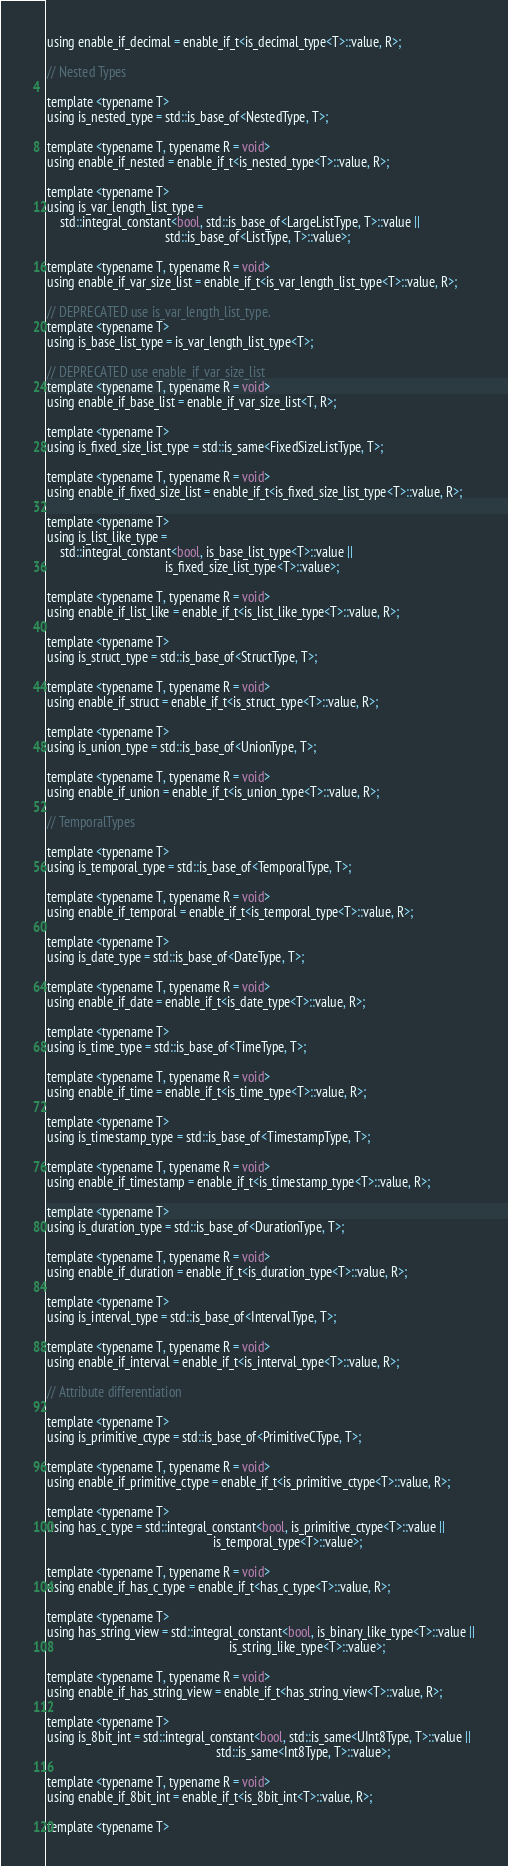Convert code to text. <code><loc_0><loc_0><loc_500><loc_500><_C_>using enable_if_decimal = enable_if_t<is_decimal_type<T>::value, R>;

// Nested Types

template <typename T>
using is_nested_type = std::is_base_of<NestedType, T>;

template <typename T, typename R = void>
using enable_if_nested = enable_if_t<is_nested_type<T>::value, R>;

template <typename T>
using is_var_length_list_type =
    std::integral_constant<bool, std::is_base_of<LargeListType, T>::value ||
                                     std::is_base_of<ListType, T>::value>;

template <typename T, typename R = void>
using enable_if_var_size_list = enable_if_t<is_var_length_list_type<T>::value, R>;

// DEPRECATED use is_var_length_list_type.
template <typename T>
using is_base_list_type = is_var_length_list_type<T>;

// DEPRECATED use enable_if_var_size_list
template <typename T, typename R = void>
using enable_if_base_list = enable_if_var_size_list<T, R>;

template <typename T>
using is_fixed_size_list_type = std::is_same<FixedSizeListType, T>;

template <typename T, typename R = void>
using enable_if_fixed_size_list = enable_if_t<is_fixed_size_list_type<T>::value, R>;

template <typename T>
using is_list_like_type =
    std::integral_constant<bool, is_base_list_type<T>::value ||
                                     is_fixed_size_list_type<T>::value>;

template <typename T, typename R = void>
using enable_if_list_like = enable_if_t<is_list_like_type<T>::value, R>;

template <typename T>
using is_struct_type = std::is_base_of<StructType, T>;

template <typename T, typename R = void>
using enable_if_struct = enable_if_t<is_struct_type<T>::value, R>;

template <typename T>
using is_union_type = std::is_base_of<UnionType, T>;

template <typename T, typename R = void>
using enable_if_union = enable_if_t<is_union_type<T>::value, R>;

// TemporalTypes

template <typename T>
using is_temporal_type = std::is_base_of<TemporalType, T>;

template <typename T, typename R = void>
using enable_if_temporal = enable_if_t<is_temporal_type<T>::value, R>;

template <typename T>
using is_date_type = std::is_base_of<DateType, T>;

template <typename T, typename R = void>
using enable_if_date = enable_if_t<is_date_type<T>::value, R>;

template <typename T>
using is_time_type = std::is_base_of<TimeType, T>;

template <typename T, typename R = void>
using enable_if_time = enable_if_t<is_time_type<T>::value, R>;

template <typename T>
using is_timestamp_type = std::is_base_of<TimestampType, T>;

template <typename T, typename R = void>
using enable_if_timestamp = enable_if_t<is_timestamp_type<T>::value, R>;

template <typename T>
using is_duration_type = std::is_base_of<DurationType, T>;

template <typename T, typename R = void>
using enable_if_duration = enable_if_t<is_duration_type<T>::value, R>;

template <typename T>
using is_interval_type = std::is_base_of<IntervalType, T>;

template <typename T, typename R = void>
using enable_if_interval = enable_if_t<is_interval_type<T>::value, R>;

// Attribute differentiation

template <typename T>
using is_primitive_ctype = std::is_base_of<PrimitiveCType, T>;

template <typename T, typename R = void>
using enable_if_primitive_ctype = enable_if_t<is_primitive_ctype<T>::value, R>;

template <typename T>
using has_c_type = std::integral_constant<bool, is_primitive_ctype<T>::value ||
                                                    is_temporal_type<T>::value>;

template <typename T, typename R = void>
using enable_if_has_c_type = enable_if_t<has_c_type<T>::value, R>;

template <typename T>
using has_string_view = std::integral_constant<bool, is_binary_like_type<T>::value ||
                                                         is_string_like_type<T>::value>;

template <typename T, typename R = void>
using enable_if_has_string_view = enable_if_t<has_string_view<T>::value, R>;

template <typename T>
using is_8bit_int = std::integral_constant<bool, std::is_same<UInt8Type, T>::value ||
                                                     std::is_same<Int8Type, T>::value>;

template <typename T, typename R = void>
using enable_if_8bit_int = enable_if_t<is_8bit_int<T>::value, R>;

template <typename T></code> 